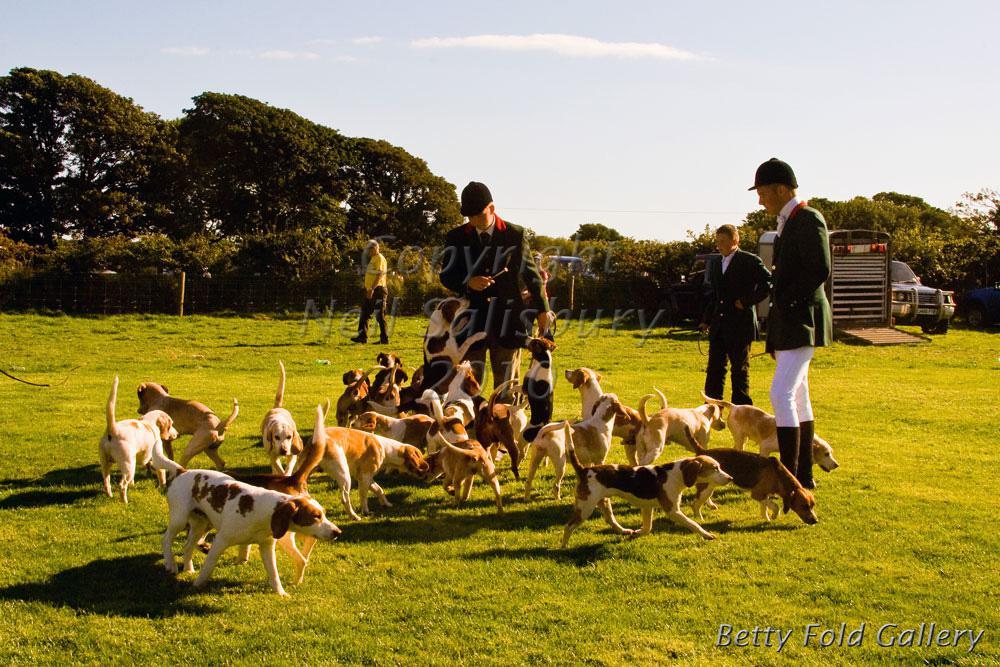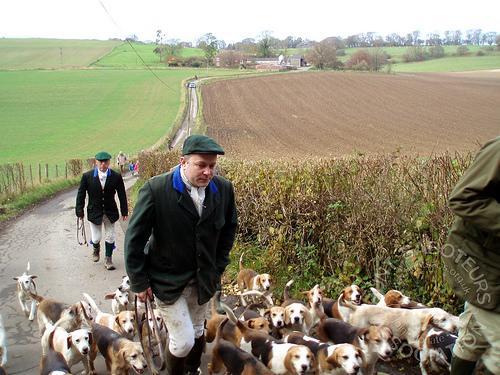The first image is the image on the left, the second image is the image on the right. For the images displayed, is the sentence "at least one image shows no sky line" factually correct? Answer yes or no. No. The first image is the image on the left, the second image is the image on the right. Assess this claim about the two images: "There is no more than two people in both images.". Correct or not? Answer yes or no. No. 